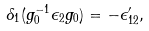Convert formula to latex. <formula><loc_0><loc_0><loc_500><loc_500>\delta _ { 1 } ( g _ { 0 } ^ { - 1 } \epsilon _ { 2 } g _ { 0 } ) = - \epsilon ^ { \prime } _ { 1 2 } ,</formula> 